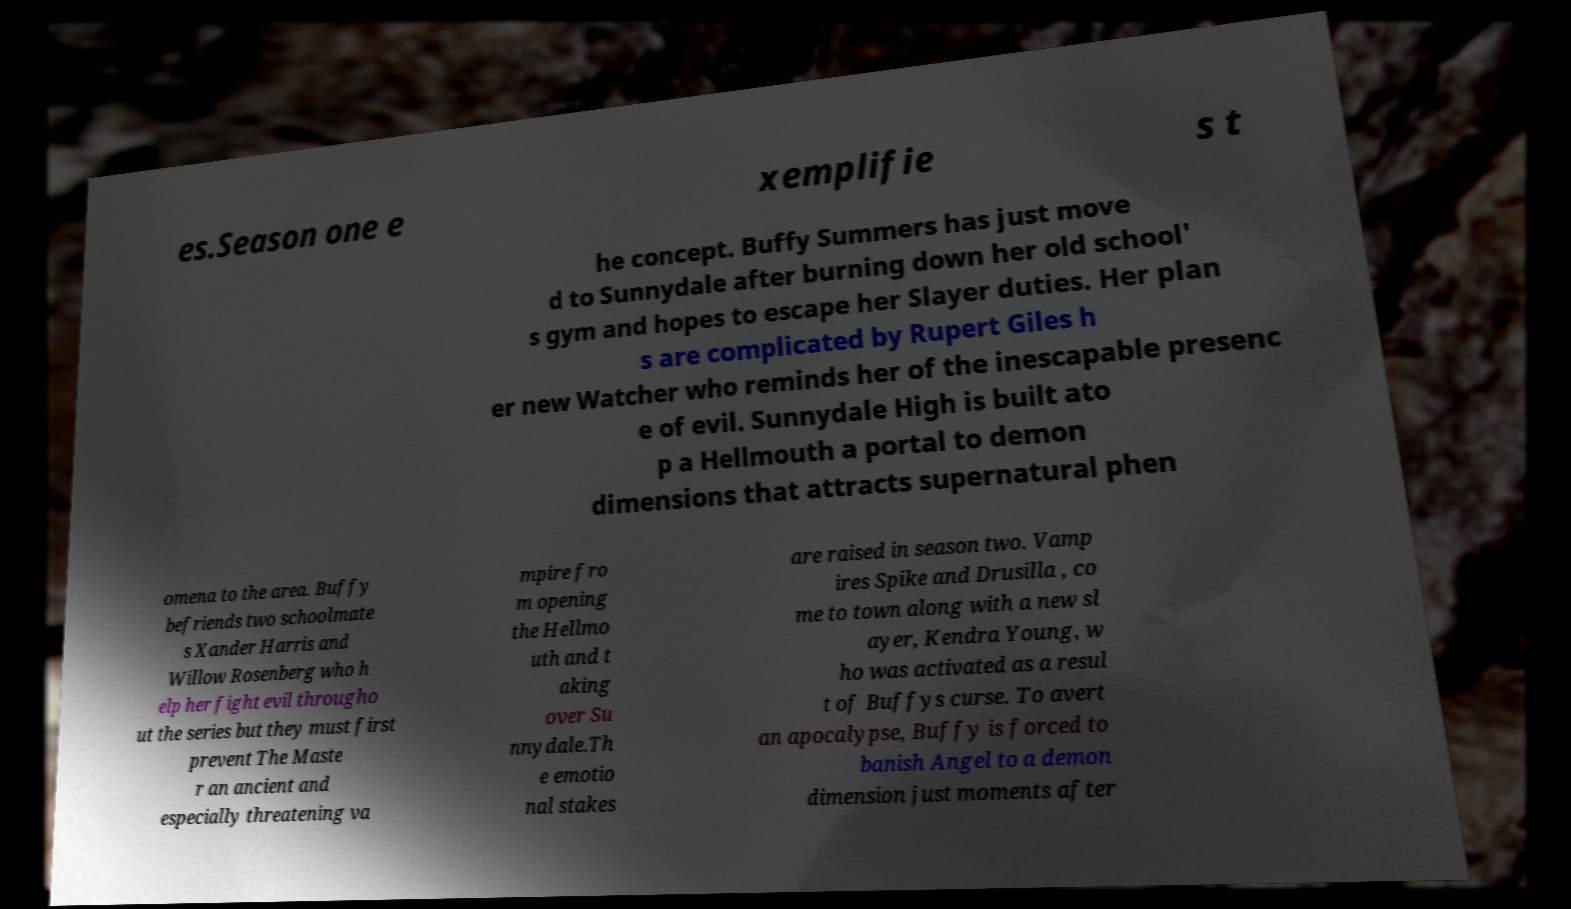I need the written content from this picture converted into text. Can you do that? es.Season one e xemplifie s t he concept. Buffy Summers has just move d to Sunnydale after burning down her old school' s gym and hopes to escape her Slayer duties. Her plan s are complicated by Rupert Giles h er new Watcher who reminds her of the inescapable presenc e of evil. Sunnydale High is built ato p a Hellmouth a portal to demon dimensions that attracts supernatural phen omena to the area. Buffy befriends two schoolmate s Xander Harris and Willow Rosenberg who h elp her fight evil througho ut the series but they must first prevent The Maste r an ancient and especially threatening va mpire fro m opening the Hellmo uth and t aking over Su nnydale.Th e emotio nal stakes are raised in season two. Vamp ires Spike and Drusilla , co me to town along with a new sl ayer, Kendra Young, w ho was activated as a resul t of Buffys curse. To avert an apocalypse, Buffy is forced to banish Angel to a demon dimension just moments after 